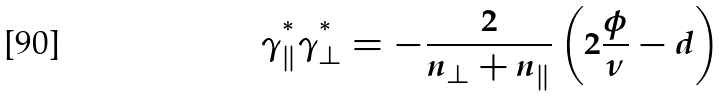<formula> <loc_0><loc_0><loc_500><loc_500>\gamma _ { \| } ^ { ^ { * } } \gamma _ { \perp } ^ { ^ { * } } = - \frac { 2 } { n _ { \perp } + n _ { \| } } \left ( 2 \frac { \phi } { \nu } - d \right )</formula> 